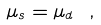<formula> <loc_0><loc_0><loc_500><loc_500>\mu _ { s } = \mu _ { d } \ ,</formula> 